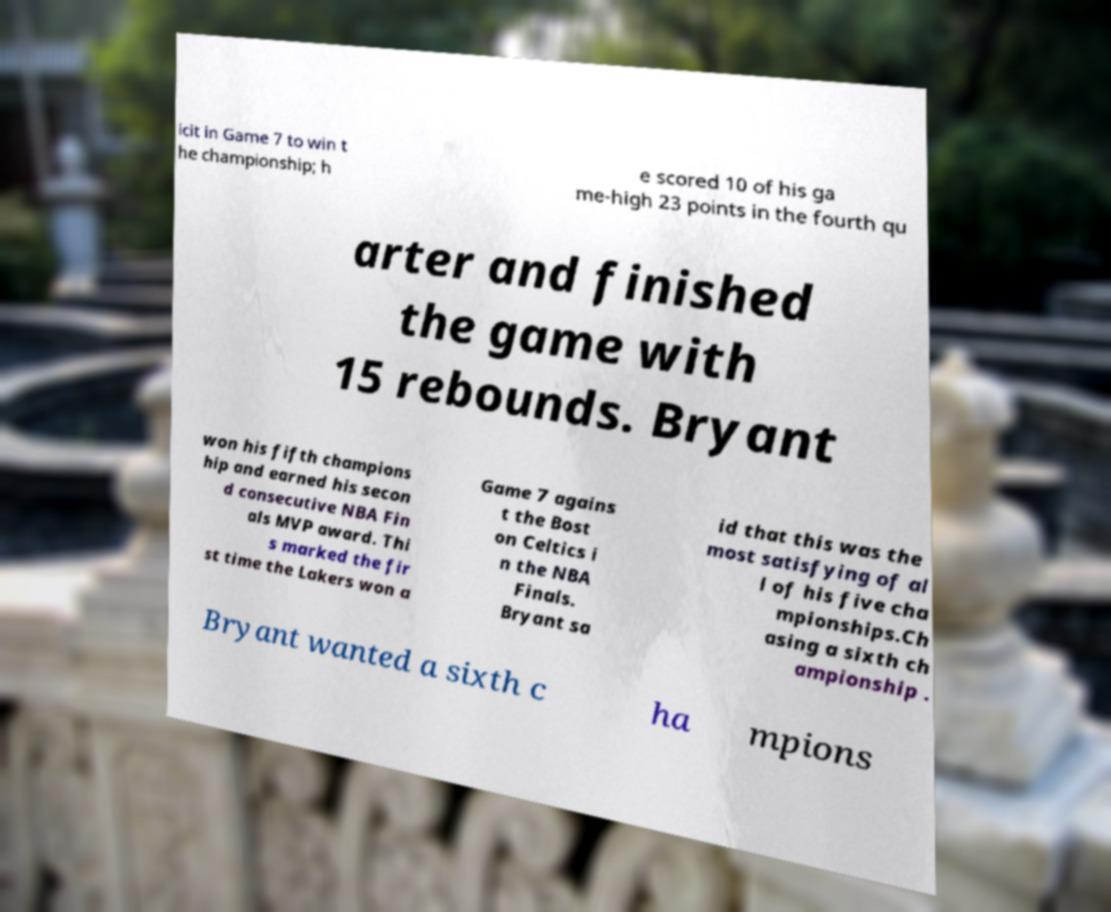I need the written content from this picture converted into text. Can you do that? icit in Game 7 to win t he championship; h e scored 10 of his ga me-high 23 points in the fourth qu arter and finished the game with 15 rebounds. Bryant won his fifth champions hip and earned his secon d consecutive NBA Fin als MVP award. Thi s marked the fir st time the Lakers won a Game 7 agains t the Bost on Celtics i n the NBA Finals. Bryant sa id that this was the most satisfying of al l of his five cha mpionships.Ch asing a sixth ch ampionship . Bryant wanted a sixth c ha mpions 